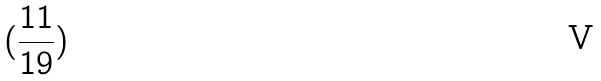<formula> <loc_0><loc_0><loc_500><loc_500>( \frac { 1 1 } { 1 9 } )</formula> 